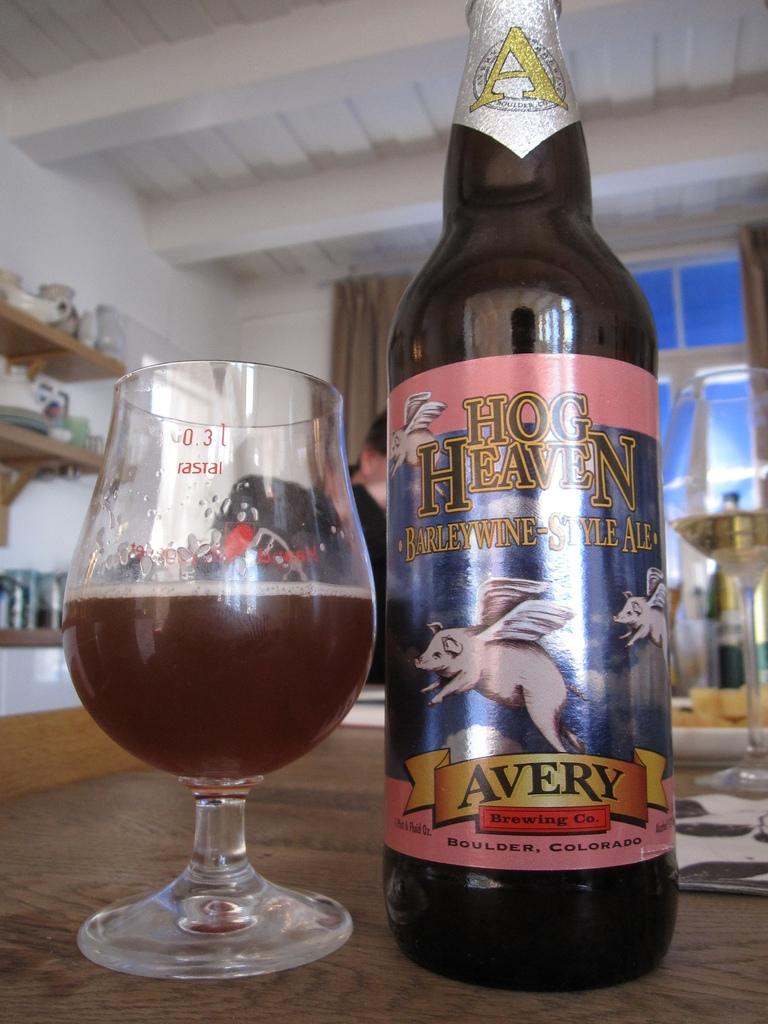<image>
Provide a brief description of the given image. A bottle of Hog Heaven ale sits next to a glass that has the ale in it. 